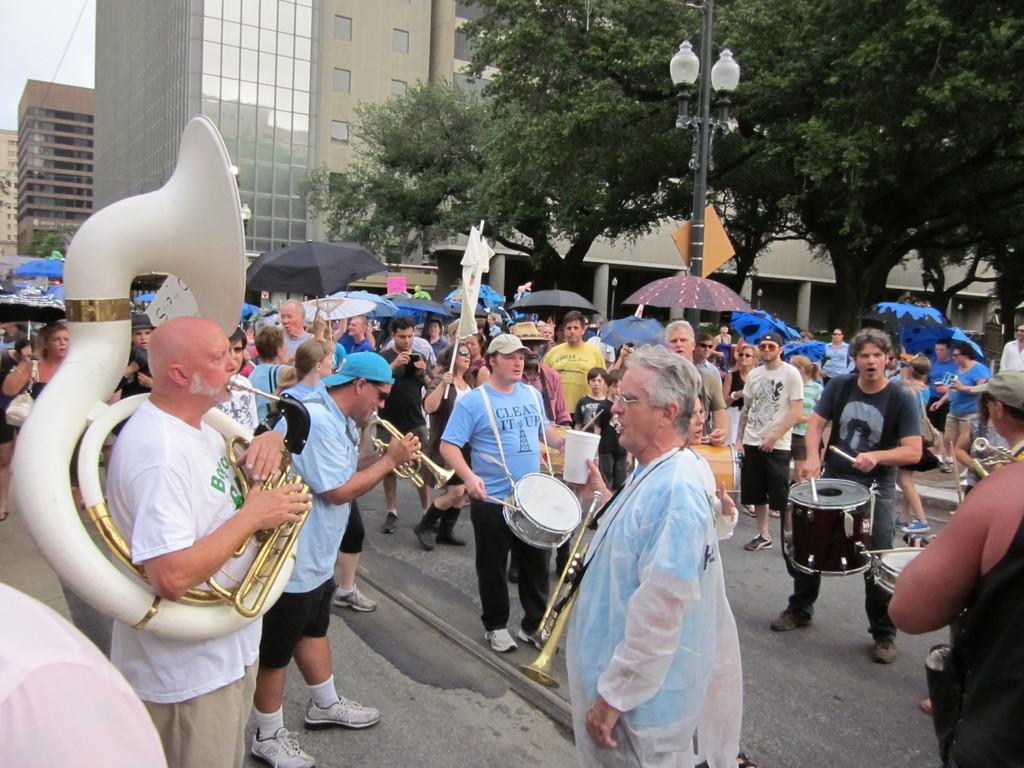Please provide a concise description of this image. This picture is clicked on a road. There are many people standing. Many of them are playing drums and trumpets. In the background there are umbrellas, table umbrella, building, trees, sky and street light. 